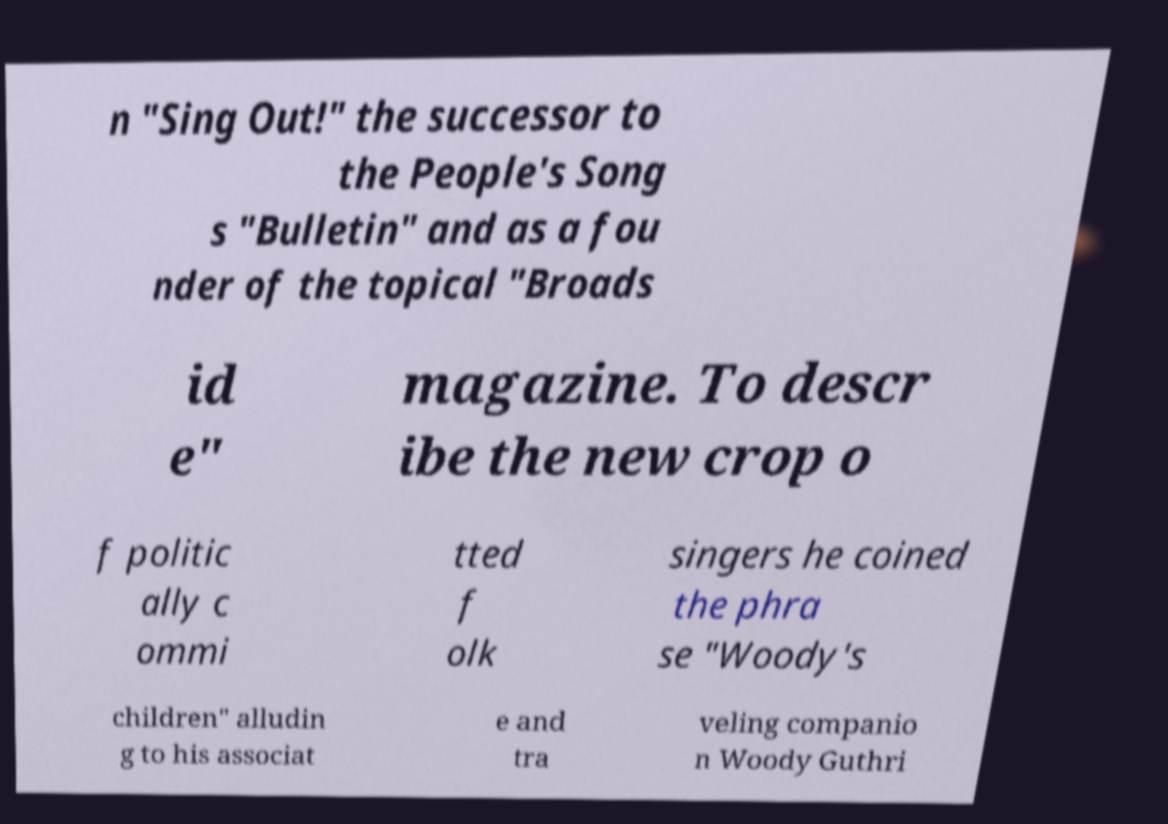Please identify and transcribe the text found in this image. n "Sing Out!" the successor to the People's Song s "Bulletin" and as a fou nder of the topical "Broads id e" magazine. To descr ibe the new crop o f politic ally c ommi tted f olk singers he coined the phra se "Woody's children" alludin g to his associat e and tra veling companio n Woody Guthri 